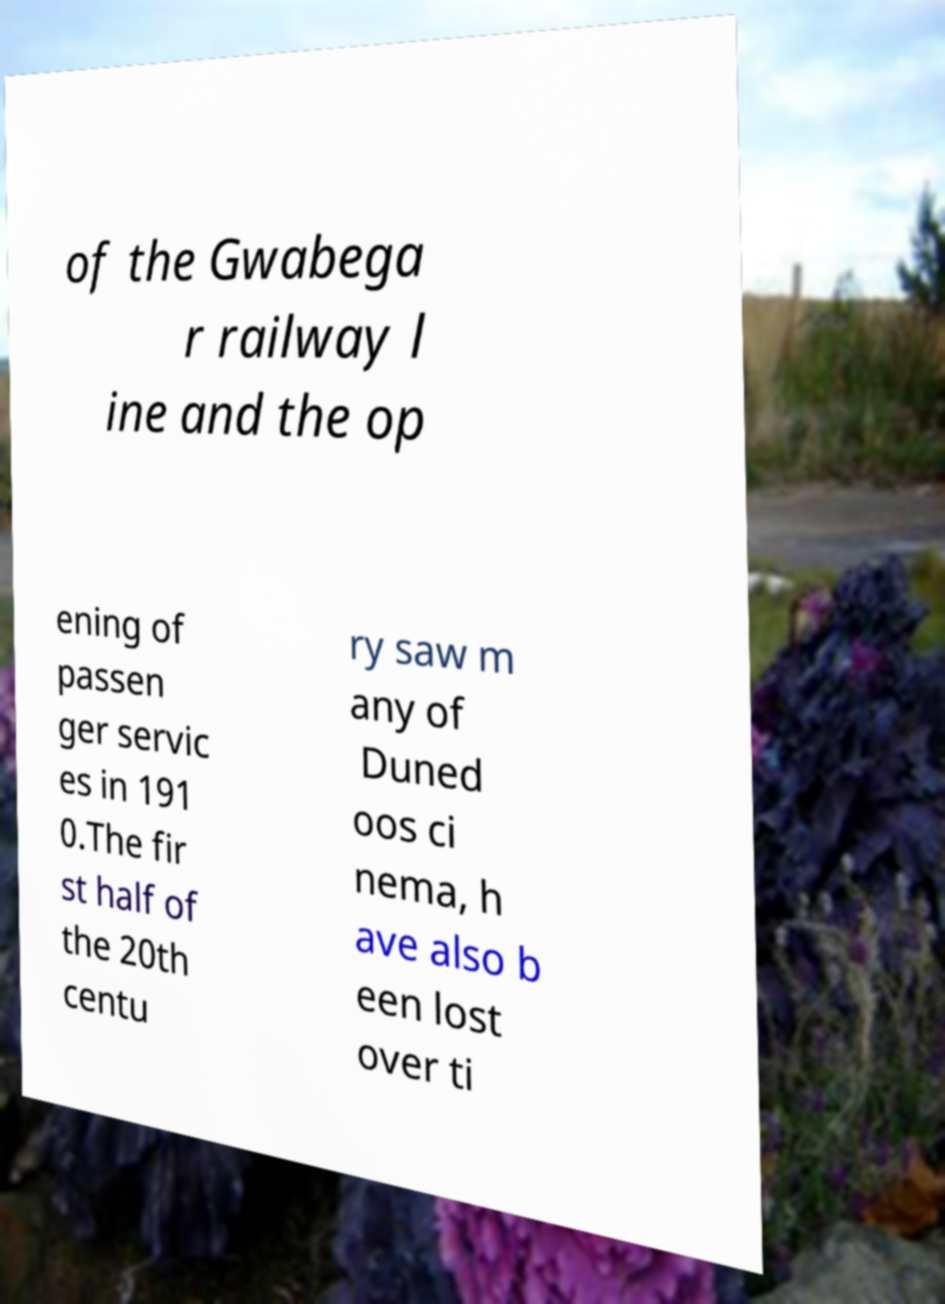Can you accurately transcribe the text from the provided image for me? of the Gwabega r railway l ine and the op ening of passen ger servic es in 191 0.The fir st half of the 20th centu ry saw m any of Duned oos ci nema, h ave also b een lost over ti 